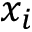Convert formula to latex. <formula><loc_0><loc_0><loc_500><loc_500>x _ { i }</formula> 